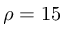Convert formula to latex. <formula><loc_0><loc_0><loc_500><loc_500>\rho = 1 5</formula> 